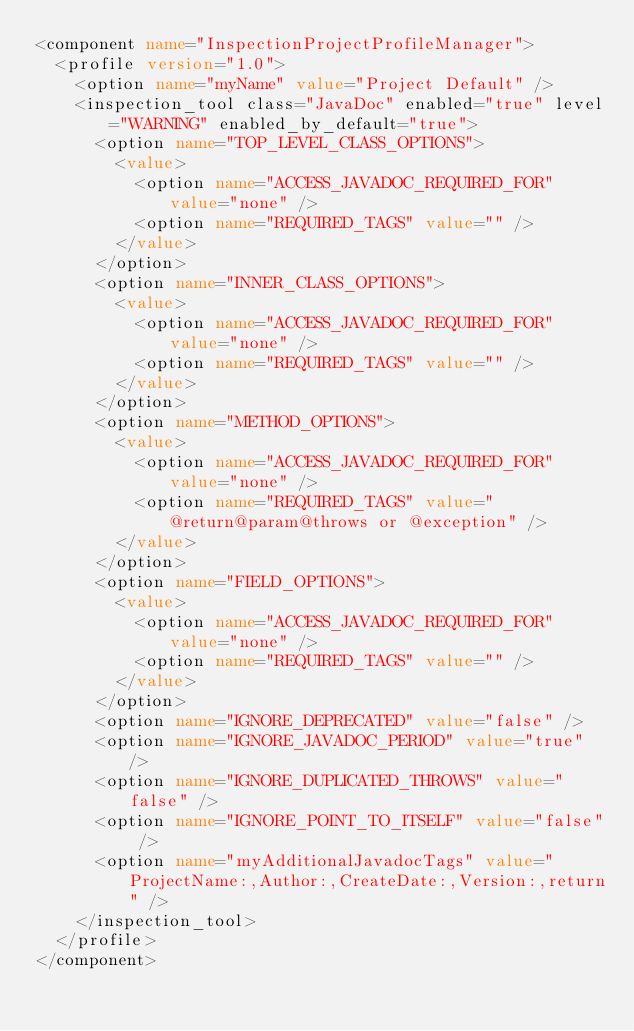Convert code to text. <code><loc_0><loc_0><loc_500><loc_500><_XML_><component name="InspectionProjectProfileManager">
  <profile version="1.0">
    <option name="myName" value="Project Default" />
    <inspection_tool class="JavaDoc" enabled="true" level="WARNING" enabled_by_default="true">
      <option name="TOP_LEVEL_CLASS_OPTIONS">
        <value>
          <option name="ACCESS_JAVADOC_REQUIRED_FOR" value="none" />
          <option name="REQUIRED_TAGS" value="" />
        </value>
      </option>
      <option name="INNER_CLASS_OPTIONS">
        <value>
          <option name="ACCESS_JAVADOC_REQUIRED_FOR" value="none" />
          <option name="REQUIRED_TAGS" value="" />
        </value>
      </option>
      <option name="METHOD_OPTIONS">
        <value>
          <option name="ACCESS_JAVADOC_REQUIRED_FOR" value="none" />
          <option name="REQUIRED_TAGS" value="@return@param@throws or @exception" />
        </value>
      </option>
      <option name="FIELD_OPTIONS">
        <value>
          <option name="ACCESS_JAVADOC_REQUIRED_FOR" value="none" />
          <option name="REQUIRED_TAGS" value="" />
        </value>
      </option>
      <option name="IGNORE_DEPRECATED" value="false" />
      <option name="IGNORE_JAVADOC_PERIOD" value="true" />
      <option name="IGNORE_DUPLICATED_THROWS" value="false" />
      <option name="IGNORE_POINT_TO_ITSELF" value="false" />
      <option name="myAdditionalJavadocTags" value="ProjectName:,Author:,CreateDate:,Version:,return" />
    </inspection_tool>
  </profile>
</component></code> 